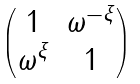Convert formula to latex. <formula><loc_0><loc_0><loc_500><loc_500>\begin{pmatrix} 1 & \omega ^ { - \xi } \\ \omega ^ { \xi } & 1 \end{pmatrix}</formula> 